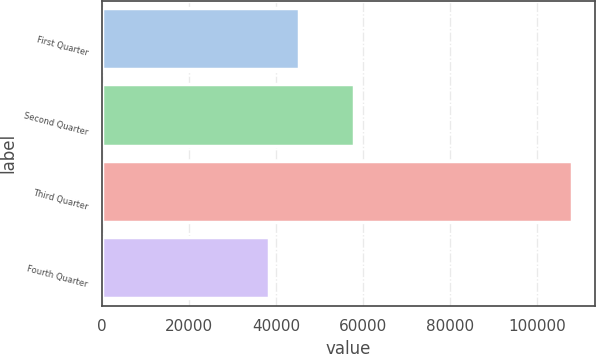Convert chart to OTSL. <chart><loc_0><loc_0><loc_500><loc_500><bar_chart><fcel>First Quarter<fcel>Second Quarter<fcel>Third Quarter<fcel>Fourth Quarter<nl><fcel>45300.6<fcel>58039<fcel>107964<fcel>38338<nl></chart> 